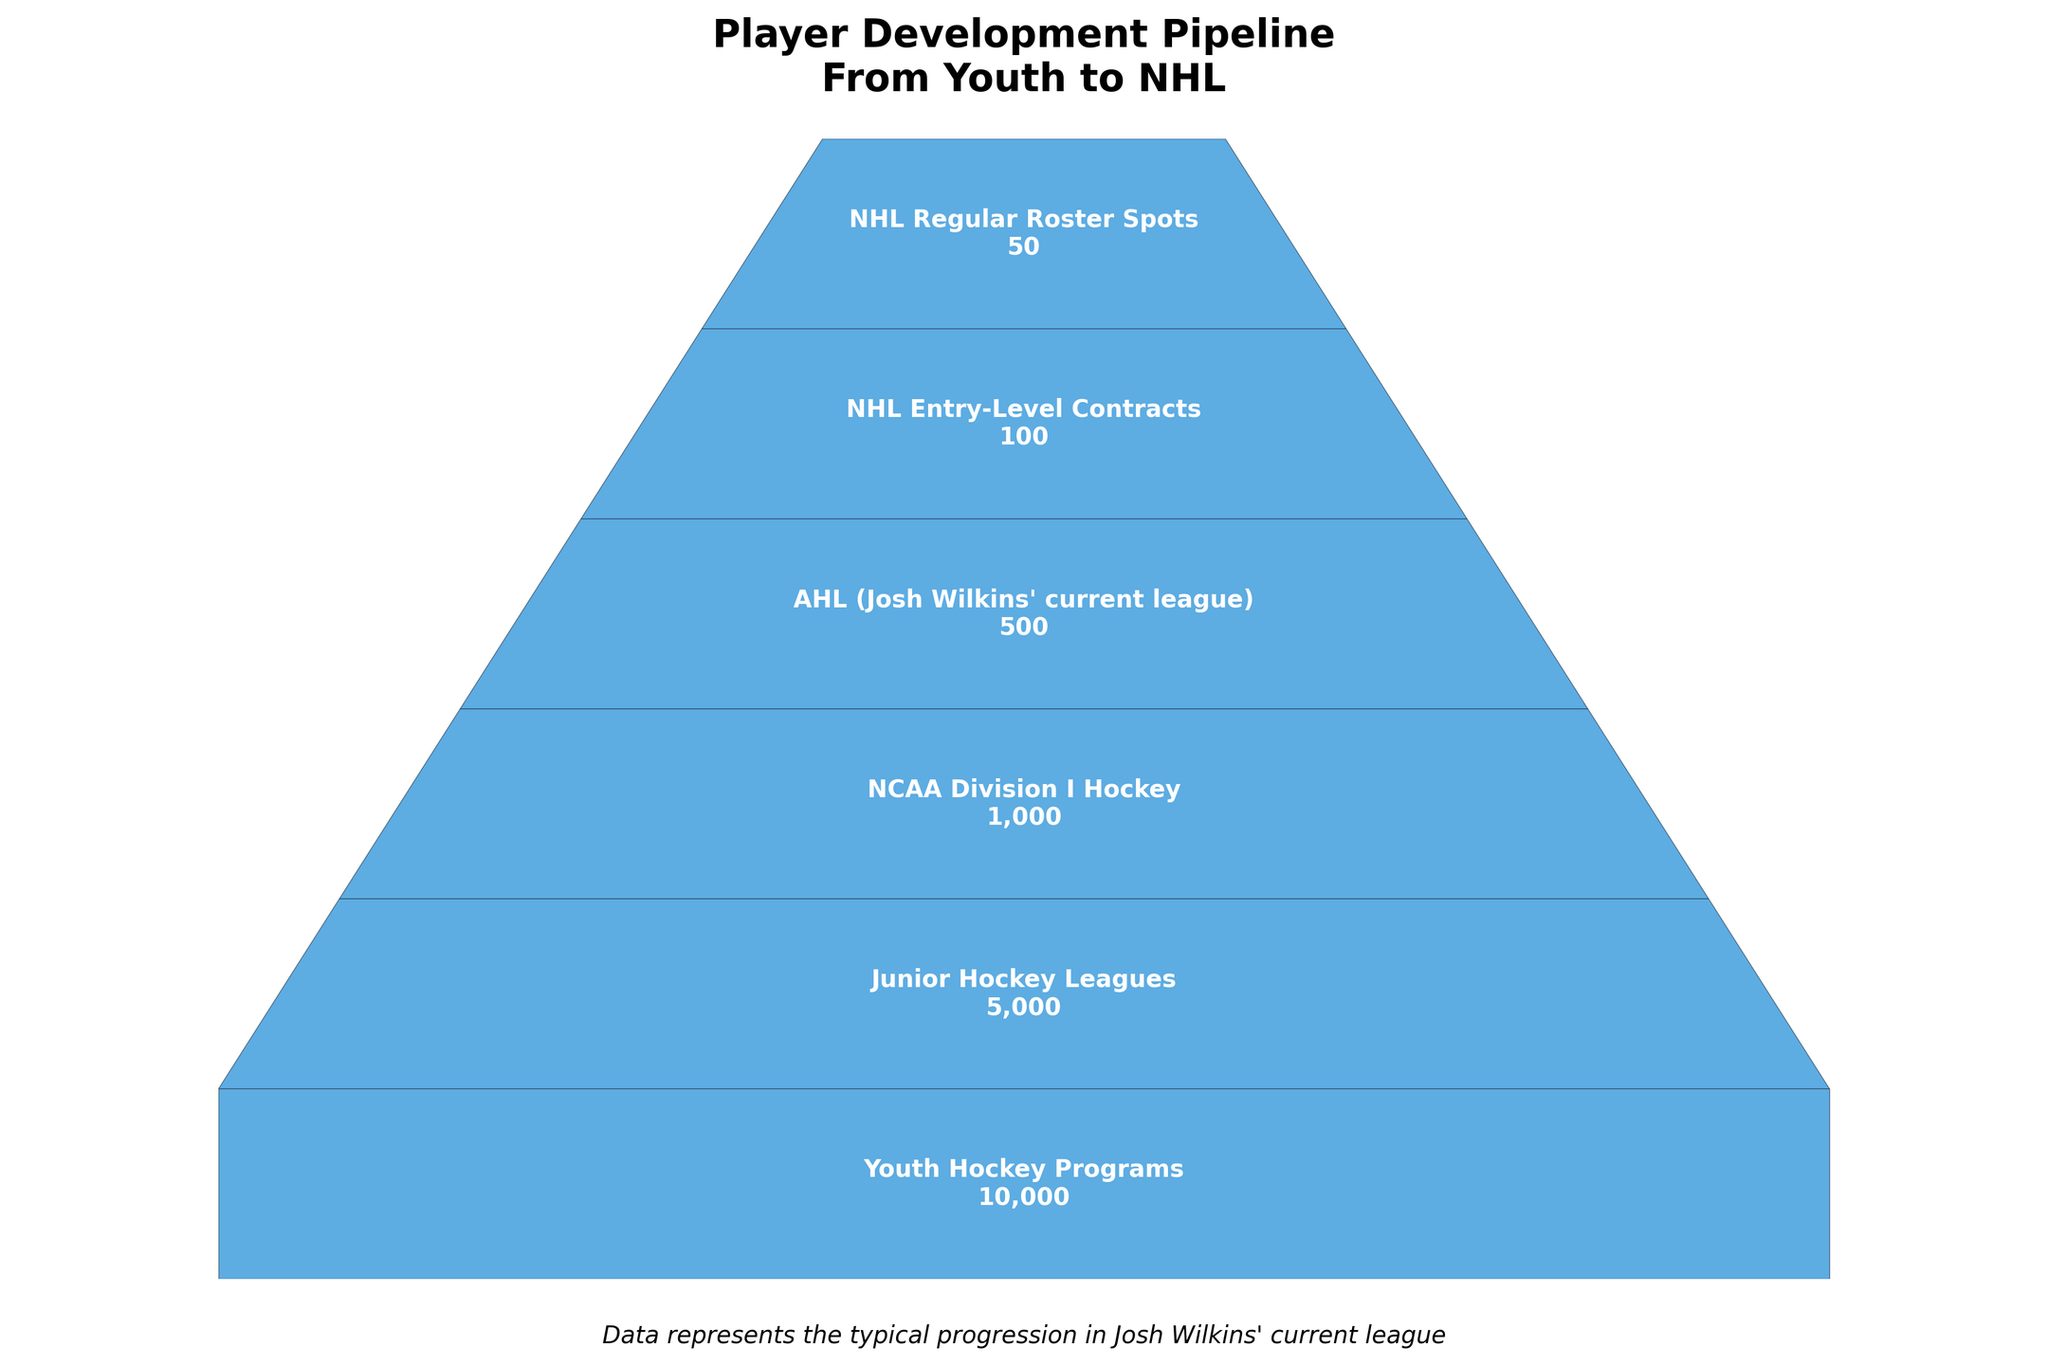What does the title of the funnel chart say? The title of the funnel chart is the first thing you see at the top of the figure. It summarizes what the chart represents. It is found centered at the top in bold font.
Answer: Player Development Pipeline From Youth to NHL How many players are there in the Junior Hockey Leagues stage? To find the number of players in the Junior Hockey Leagues stage, locate this stage in the funnel and read the number associated with it. It is placed within the funnel at that particular stage.
Answer: 5,000 Which stage has the fewest players? Identify the stage with the smallest number attached to it in the funnel chart.
Answer: NHL Regular Roster Spots How does the number of players in the AHL compare to those in the NHL Entry-Level Contracts? Compare the numbers associated with the AHL and NHL Entry-Level Contracts stages.
Answer: AHL has 500, Entry-Level Contracts has 100. AHL has more What can be inferred about the player drop-off rate from the AHL to the NHL Regular Roster Spots? Compare the numbers of players in the AHL and NHL Regular Roster Spots stages to infer the drop-off rate.
Answer: From 500 (AHL) to 50 (NHL Regular Roster Spots), the drop-off is significant 